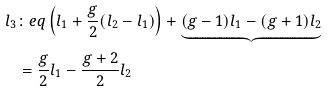<formula> <loc_0><loc_0><loc_500><loc_500>l _ { 3 } & \colon e q \left ( l _ { 1 } + \frac { g } { 2 } ( l _ { 2 } - l _ { 1 } ) \right ) + \underbrace { ( g - 1 ) l _ { 1 } - ( g + 1 ) l _ { 2 } } \\ & = \frac { g } { 2 } l _ { 1 } - \frac { g + 2 } { 2 } l _ { 2 }</formula> 